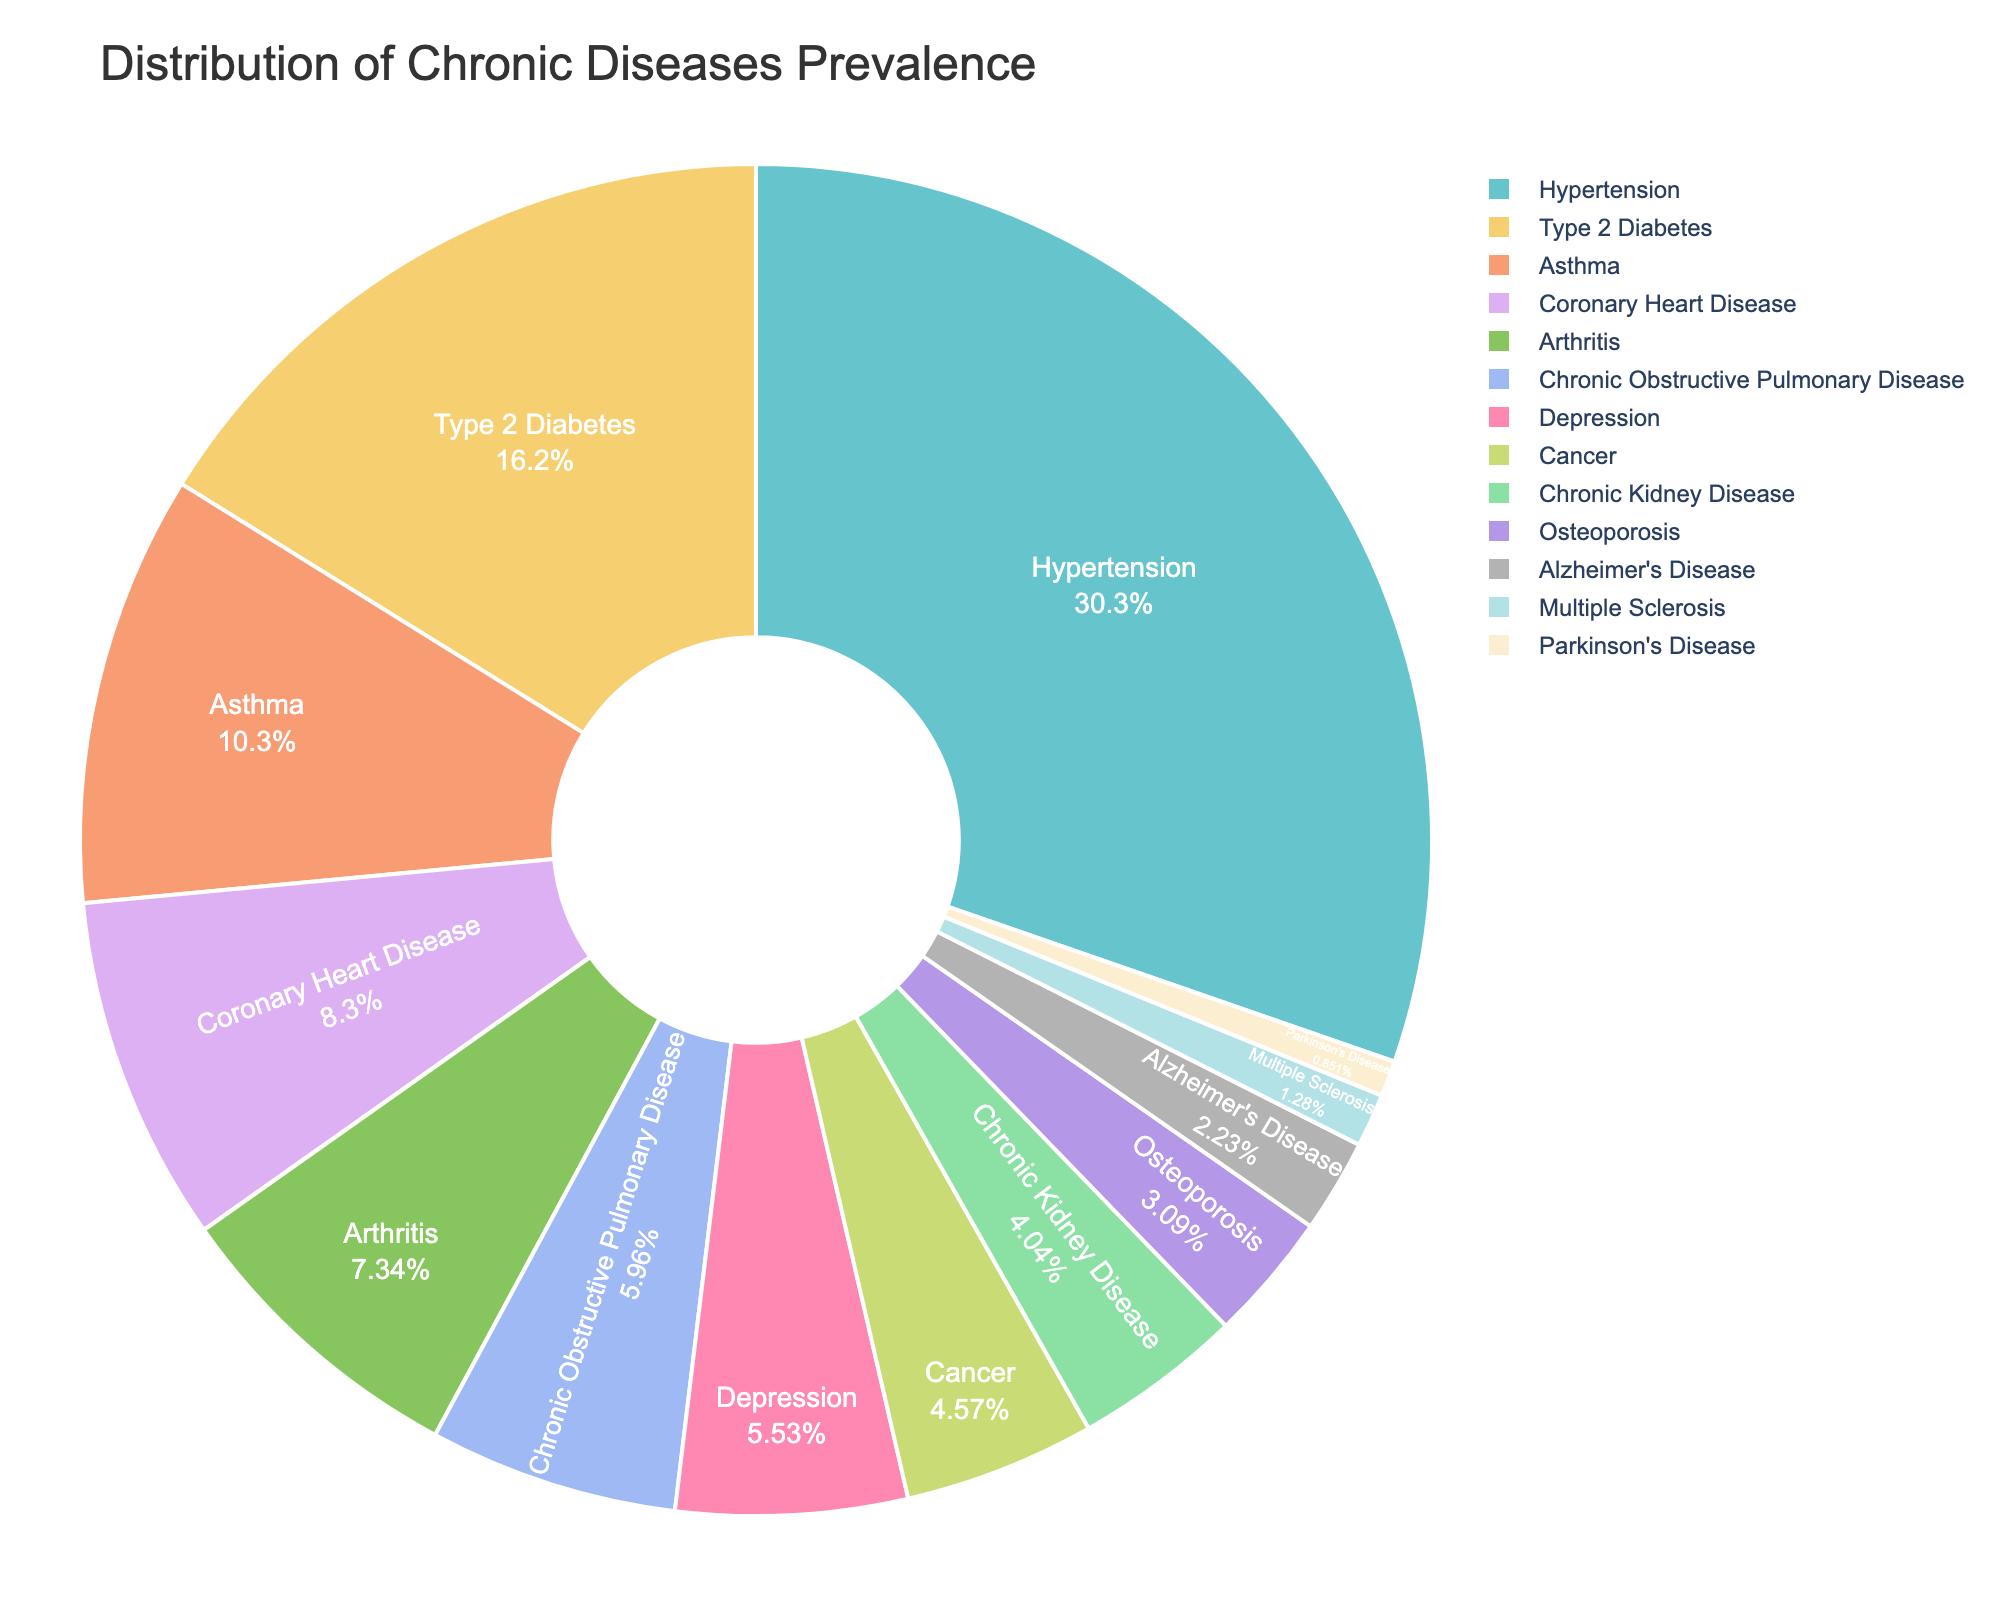What disease has the highest prevalence? By examining the figure, the disease segment with the largest size represents the disease with the highest prevalence. Hypertension's segment takes up the most space.
Answer: Hypertension Which disease has a lower prevalence: Type 2 Diabetes or Depression? By comparing the sizes of the segments representing Type 2 Diabetes and Depression, Type 2 Diabetes has a larger segment than Depression.
Answer: Depression What is the combined prevalence of Asthma and Chronic Obstructive Pulmonary Disease? Locate the segments for Asthma (9.7%) and Chronic Obstructive Pulmonary Disease (5.6%), and add these values together: 9.7 + 5.6 = 15.3.
Answer: 15.3% How many diseases have a prevalence rate lower than 5%? Count the number of segments where the prevalence rates indicated on the segments are below 5%. They are Cancer, Chronic Kidney Disease, Osteoporosis, Alzheimer's Disease, Multiple Sclerosis, and Parkinson's Disease. There are 6 diseases.
Answer: 6 Which disease's segment is the darkest in color? By observing the colors of each segment, Alzheimer's Disease has the darkest color segment among all the diseases.
Answer: Alzheimer's Disease Is the prevalence of Arthritis greater than that of Coronary Heart Disease? By comparing the sizes/percentages of the segments for Arthritis (6.9%) and Coronary Heart Disease (7.8%), Coronary Heart Disease has a higher prevalence.
Answer: No What is the difference in prevalence between the most common and least common chronic disease? The most common disease is Hypertension (28.5%), and the least common disease is Parkinson's Disease (0.8%). Subtracting these values: 28.5 - 0.8 = 27.7.
Answer: 27.7% What is the sum of the prevalence rates for diseases with a prevalence rate greater than 10%? The diseases are Hypertension (28.5%) and Type 2 Diabetes (15.2%). Summing these values: 28.5 + 15.2 = 43.7.
Answer: 43.7% Which two diseases have the closest prevalence rates? By examining the figure, Asthma (9.7%) and Coronary Heart Disease (7.8%) have the closest prevalence rates of all the diseases.
Answer: Asthma and Coronary Heart Disease 